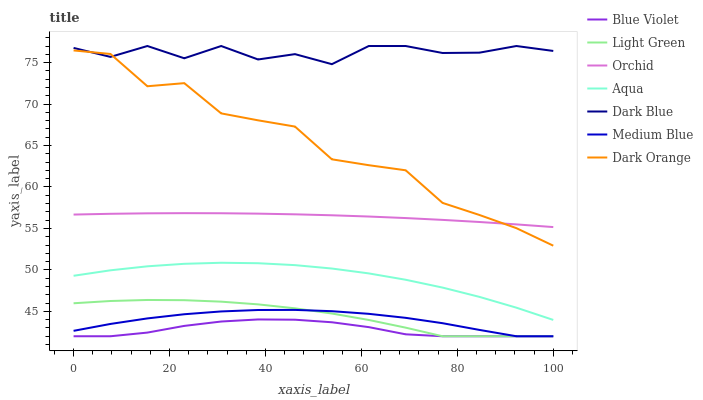Does Aqua have the minimum area under the curve?
Answer yes or no. No. Does Aqua have the maximum area under the curve?
Answer yes or no. No. Is Aqua the smoothest?
Answer yes or no. No. Is Aqua the roughest?
Answer yes or no. No. Does Aqua have the lowest value?
Answer yes or no. No. Does Aqua have the highest value?
Answer yes or no. No. Is Light Green less than Orchid?
Answer yes or no. Yes. Is Orchid greater than Blue Violet?
Answer yes or no. Yes. Does Light Green intersect Orchid?
Answer yes or no. No. 